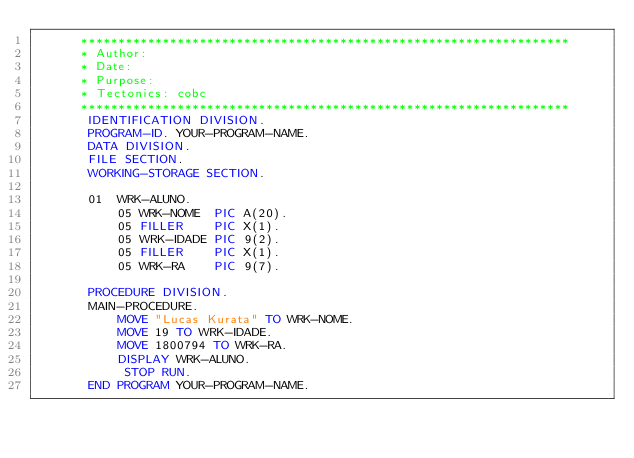<code> <loc_0><loc_0><loc_500><loc_500><_COBOL_>      ******************************************************************
      * Author:
      * Date:
      * Purpose:
      * Tectonics: cobc
      ******************************************************************
       IDENTIFICATION DIVISION.
       PROGRAM-ID. YOUR-PROGRAM-NAME.
       DATA DIVISION.
       FILE SECTION.
       WORKING-STORAGE SECTION.

       01  WRK-ALUNO.
           05 WRK-NOME  PIC A(20).
           05 FILLER    PIC X(1).
           05 WRK-IDADE PIC 9(2).
           05 FILLER    PIC X(1).
           05 WRK-RA    PIC 9(7).

       PROCEDURE DIVISION.
       MAIN-PROCEDURE.
           MOVE "Lucas Kurata" TO WRK-NOME.
           MOVE 19 TO WRK-IDADE.
           MOVE 1800794 TO WRK-RA.
           DISPLAY WRK-ALUNO.
            STOP RUN.
       END PROGRAM YOUR-PROGRAM-NAME.
</code> 